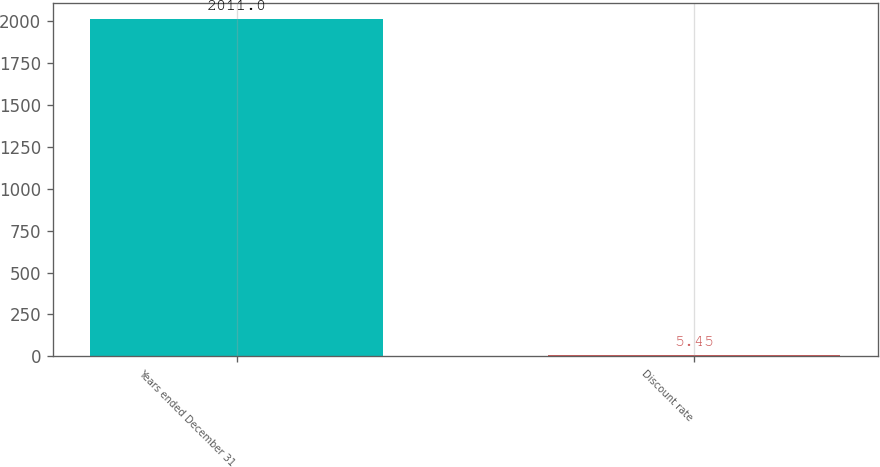<chart> <loc_0><loc_0><loc_500><loc_500><bar_chart><fcel>Years ended December 31<fcel>Discount rate<nl><fcel>2011<fcel>5.45<nl></chart> 